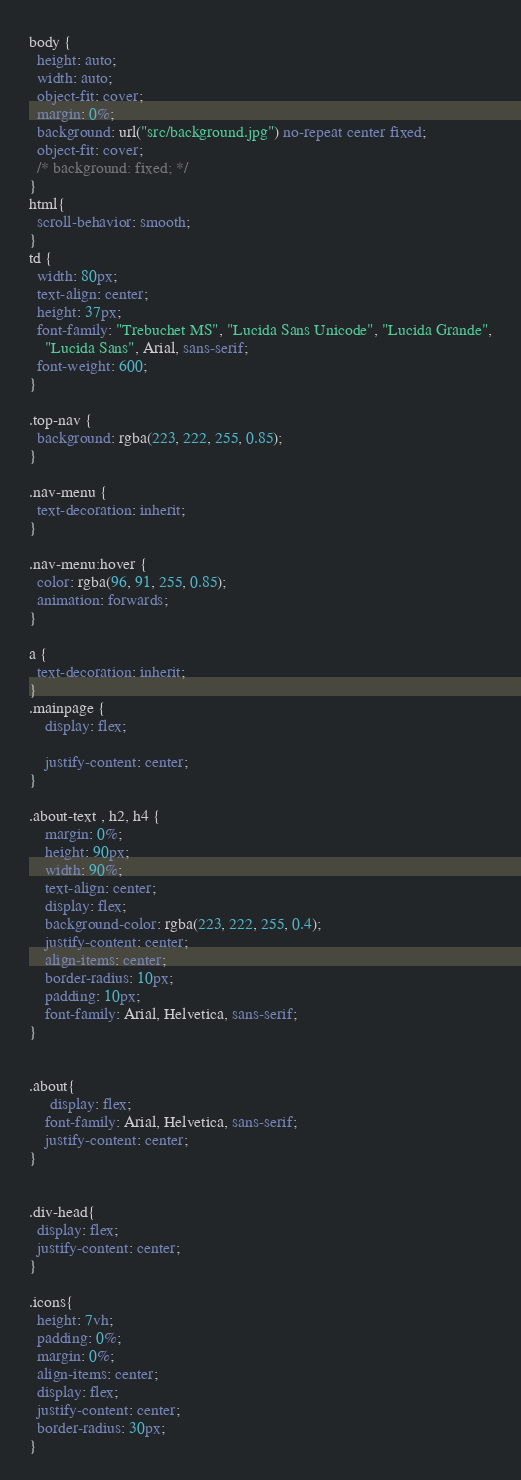Convert code to text. <code><loc_0><loc_0><loc_500><loc_500><_CSS_>body {
  height: auto;
  width: auto;
  object-fit: cover;
  margin: 0%;
  background: url("src/background.jpg") no-repeat center fixed;
  object-fit: cover;
  /* background: fixed; */
}
html{
  scroll-behavior: smooth;
}
td {
  width: 80px;
  text-align: center;
  height: 37px;
  font-family: "Trebuchet MS", "Lucida Sans Unicode", "Lucida Grande",
    "Lucida Sans", Arial, sans-serif;
  font-weight: 600;
}

.top-nav {
  background: rgba(223, 222, 255, 0.85);
}

.nav-menu {
  text-decoration: inherit;
}

.nav-menu:hover {
  color: rgba(96, 91, 255, 0.85);
  animation: forwards;
}

a {
  text-decoration: inherit;
}
.mainpage {
    display: flex;
   
    justify-content: center;
}

.about-text , h2, h4 {
    margin: 0%;
    height: 90px;
    width: 90%;
    text-align: center;
    display: flex;
    background-color: rgba(223, 222, 255, 0.4);
    justify-content: center;
    align-items: center;
    border-radius: 10px;
    padding: 10px;
    font-family: Arial, Helvetica, sans-serif;
}


.about{
     display: flex;
    font-family: Arial, Helvetica, sans-serif;
    justify-content: center;
}


.div-head{
  display: flex;
  justify-content: center;
}

.icons{
  height: 7vh;
  padding: 0%;
  margin: 0%;
  align-items: center;
  display: flex;
  justify-content: center;
  border-radius: 30px;
}</code> 